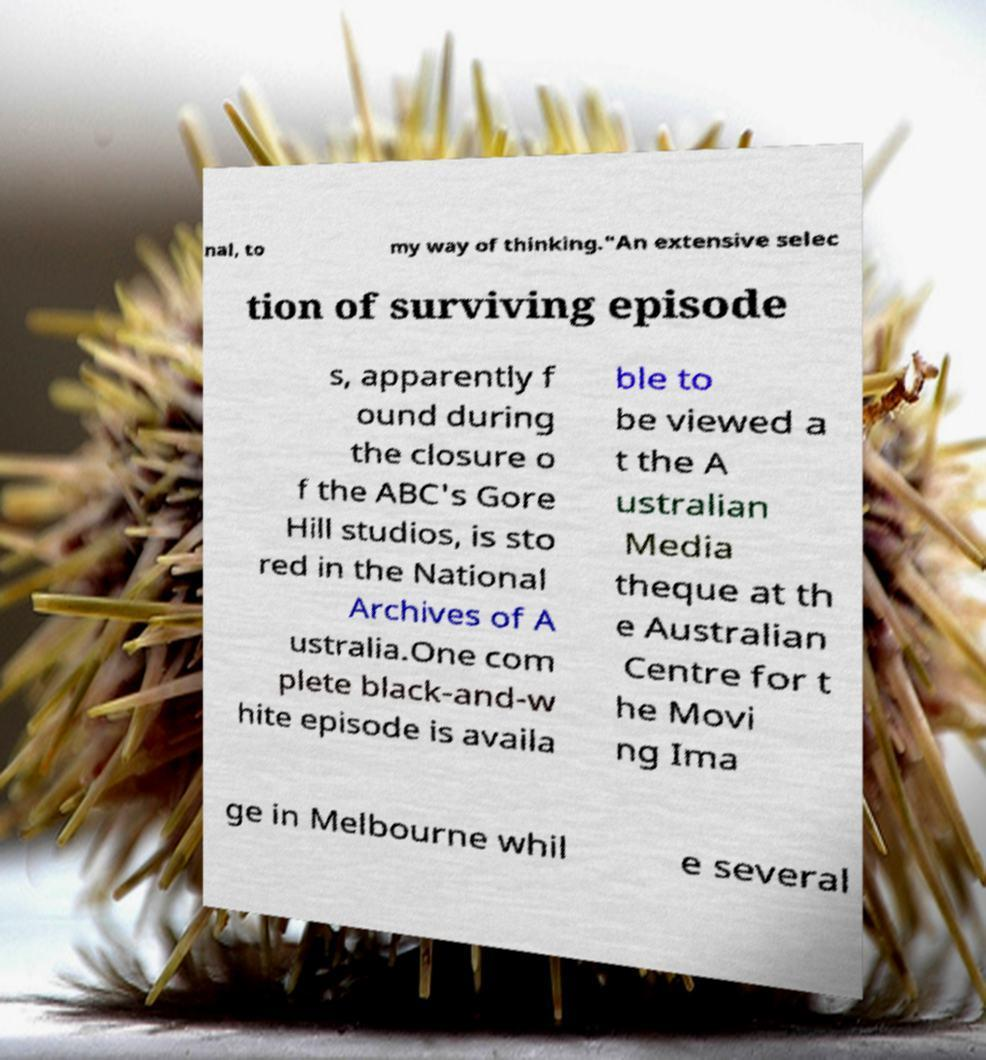What messages or text are displayed in this image? I need them in a readable, typed format. nal, to my way of thinking."An extensive selec tion of surviving episode s, apparently f ound during the closure o f the ABC's Gore Hill studios, is sto red in the National Archives of A ustralia.One com plete black-and-w hite episode is availa ble to be viewed a t the A ustralian Media theque at th e Australian Centre for t he Movi ng Ima ge in Melbourne whil e several 